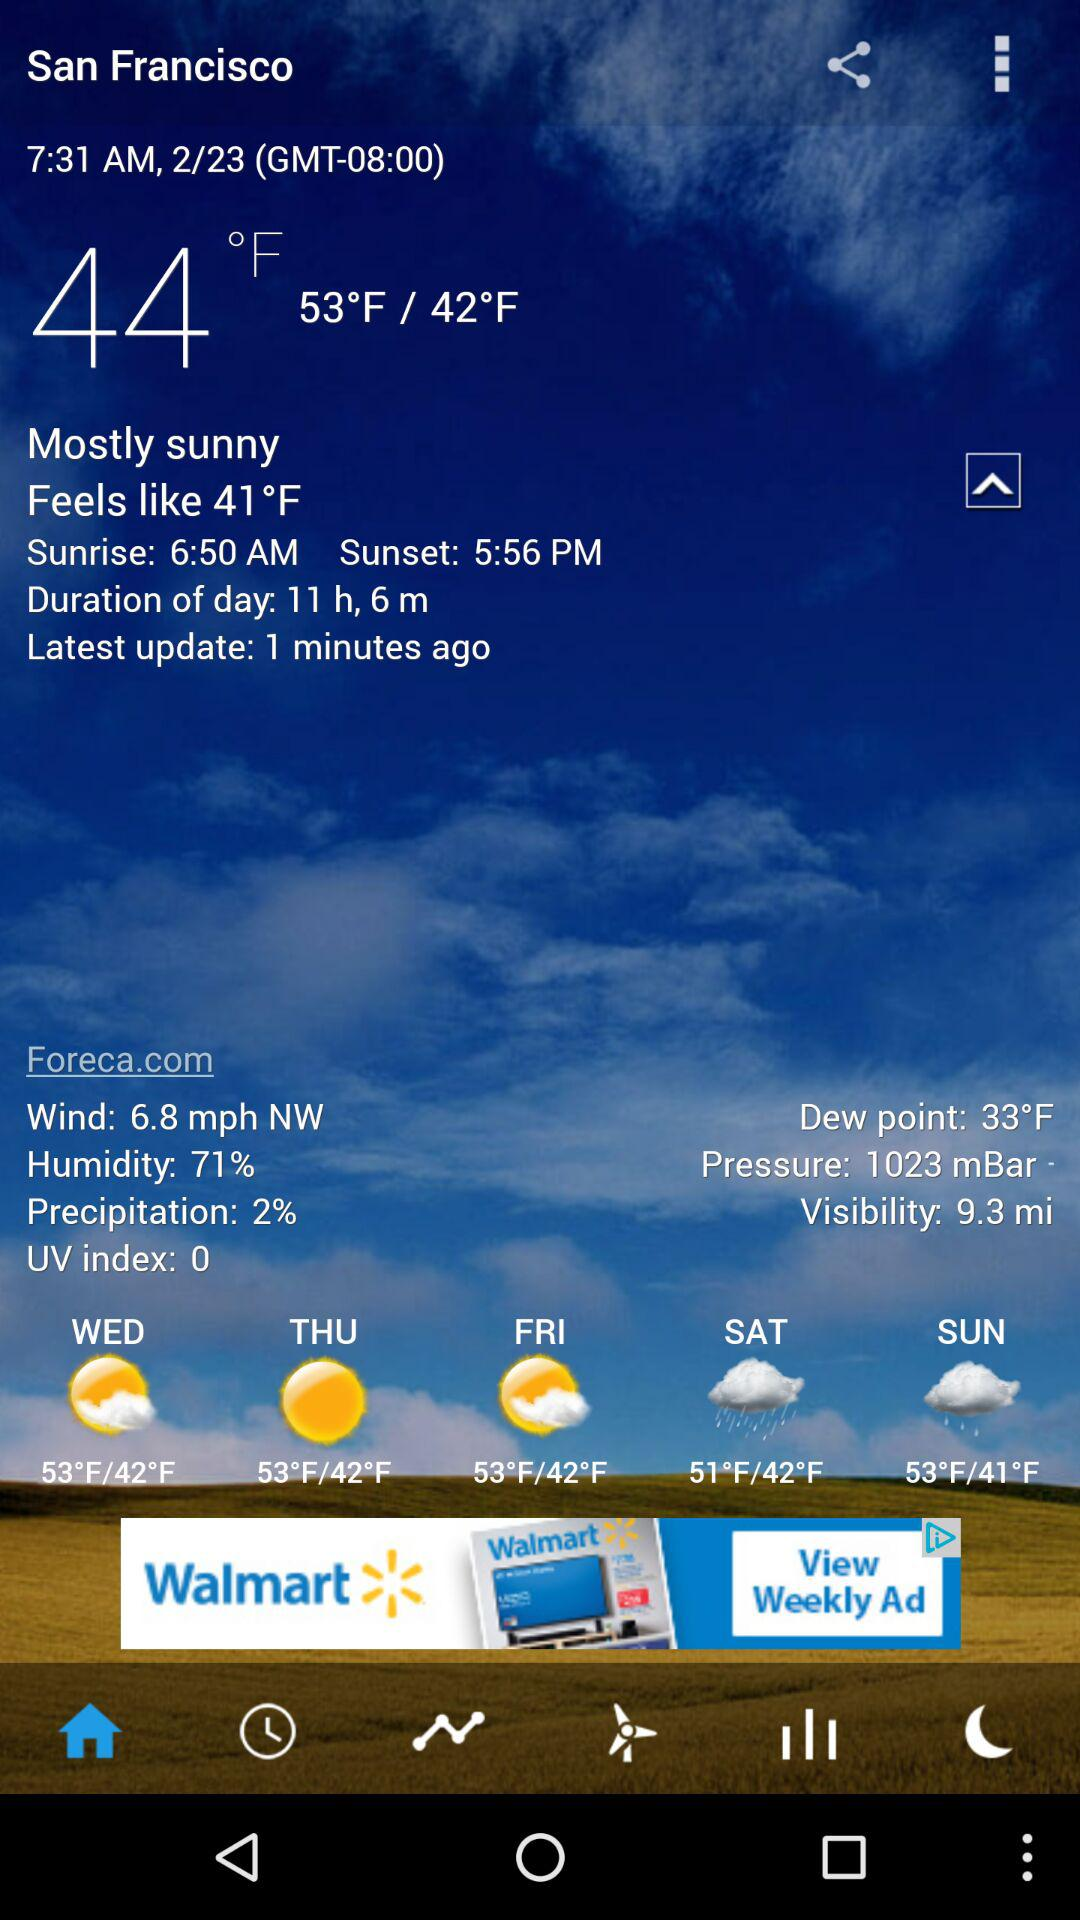What is the humidity? The humidity is 71%. 